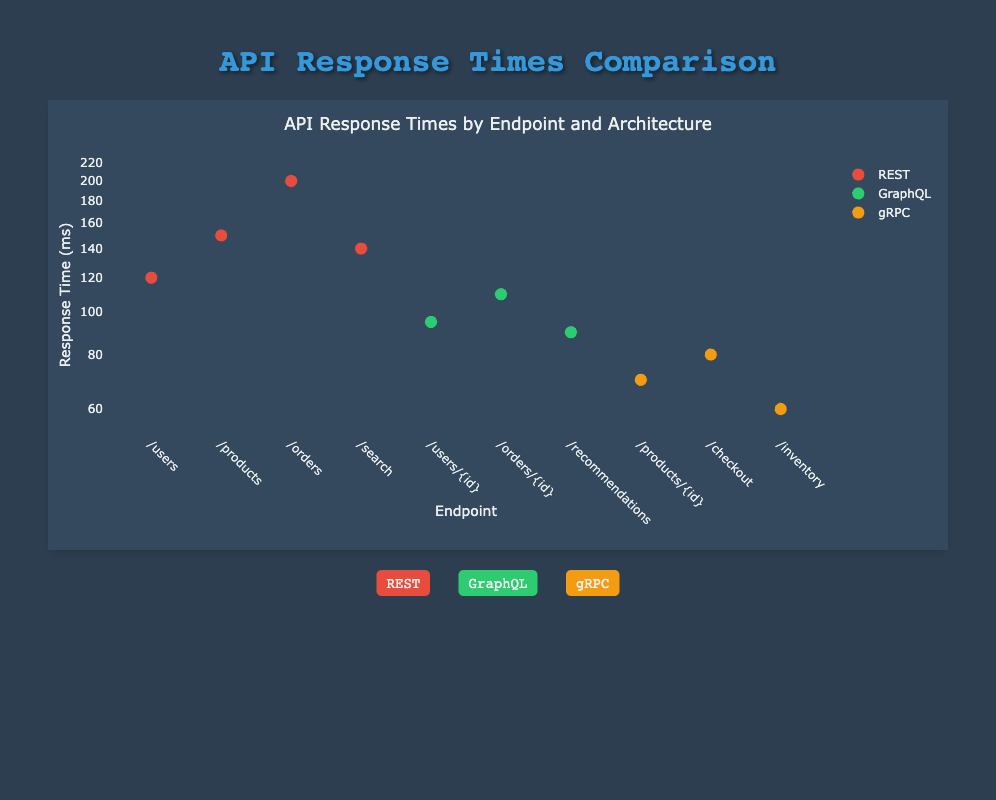What is the response time for the "/products" endpoint using REST architecture? The endpoint "/products" is explicitly listed under the REST architecture with a response time of 150 ms.
Answer: 150 ms Which endpoint has the fastest response time, and what is that time? The endpoint "/inventory" uses the gRPC architecture and has the fastest response time of 60 ms compared to other endpoints.
Answer: "/inventory", 60 ms Is the response time for the "/users/{id}" endpoint better than that of the "/orders" endpoint? The response time for "/users/{id}" is 95 ms, whereas for "/orders" it is 200 ms. Since 95 ms is less than 200 ms, the "/users/{id}" endpoint has a better response time.
Answer: Yes What is the average response time of all endpoints using GraphQL architecture? The GraphQL endpoints are "/users/{id}", "/orders/{id}", and "/recommendations" with response times of 95 ms, 110 ms, and 90 ms, respectively. Calculating the average: (95 + 110 + 90) / 3 = 95 ms.
Answer: 95 ms Which architecture has the highest response time among the listed endpoints? By reviewing the response times, REST has the highest individual maximum response time at 200 ms for the "/orders" endpoint, making it the architecture with the highest recorded response time.
Answer: REST What is the difference in response time between the slowest REST endpoint and the fastest gRPC endpoint? The slowest REST endpoint is "/orders" with a response time of 200 ms, and the fastest gRPC endpoint is "/inventory" with a response time of 60 ms. The difference is 200 - 60 = 140 ms.
Answer: 140 ms Does any endpoint in the REST architecture have a response time less than 130 ms? The REST endpoints include "/users" (120 ms) and "/search" (140 ms). Since 120 ms is less than 130 ms, there is an endpoint that meets this criterion.
Answer: Yes How many endpoints in total are evaluated for REST architecture? The data shows three REST endpoints: "/users", "/products", and "/orders", in addition to the two variable endpoints which are "/users/{id}" and "/checkout". Therefore, there are 4 REST endpoints in total assessed in the comparison.
Answer: 4 